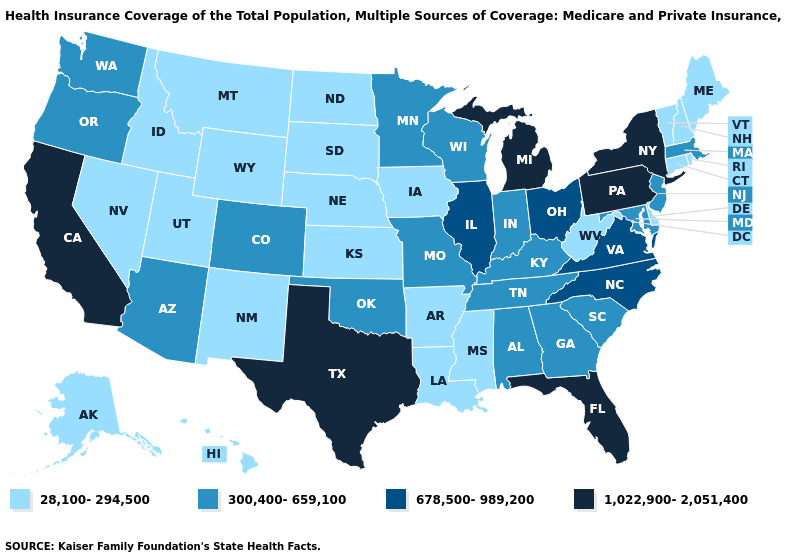Which states hav the highest value in the MidWest?
Be succinct. Michigan. Does Idaho have the same value as Maine?
Keep it brief. Yes. Name the states that have a value in the range 300,400-659,100?
Write a very short answer. Alabama, Arizona, Colorado, Georgia, Indiana, Kentucky, Maryland, Massachusetts, Minnesota, Missouri, New Jersey, Oklahoma, Oregon, South Carolina, Tennessee, Washington, Wisconsin. Among the states that border Ohio , which have the lowest value?
Concise answer only. West Virginia. What is the value of Delaware?
Be succinct. 28,100-294,500. Is the legend a continuous bar?
Answer briefly. No. What is the lowest value in the South?
Quick response, please. 28,100-294,500. How many symbols are there in the legend?
Answer briefly. 4. Does Mississippi have a higher value than Missouri?
Keep it brief. No. Name the states that have a value in the range 678,500-989,200?
Short answer required. Illinois, North Carolina, Ohio, Virginia. What is the highest value in the West ?
Give a very brief answer. 1,022,900-2,051,400. What is the lowest value in the South?
Answer briefly. 28,100-294,500. Name the states that have a value in the range 300,400-659,100?
Short answer required. Alabama, Arizona, Colorado, Georgia, Indiana, Kentucky, Maryland, Massachusetts, Minnesota, Missouri, New Jersey, Oklahoma, Oregon, South Carolina, Tennessee, Washington, Wisconsin. Name the states that have a value in the range 300,400-659,100?
Answer briefly. Alabama, Arizona, Colorado, Georgia, Indiana, Kentucky, Maryland, Massachusetts, Minnesota, Missouri, New Jersey, Oklahoma, Oregon, South Carolina, Tennessee, Washington, Wisconsin. Does Michigan have the highest value in the USA?
Give a very brief answer. Yes. 